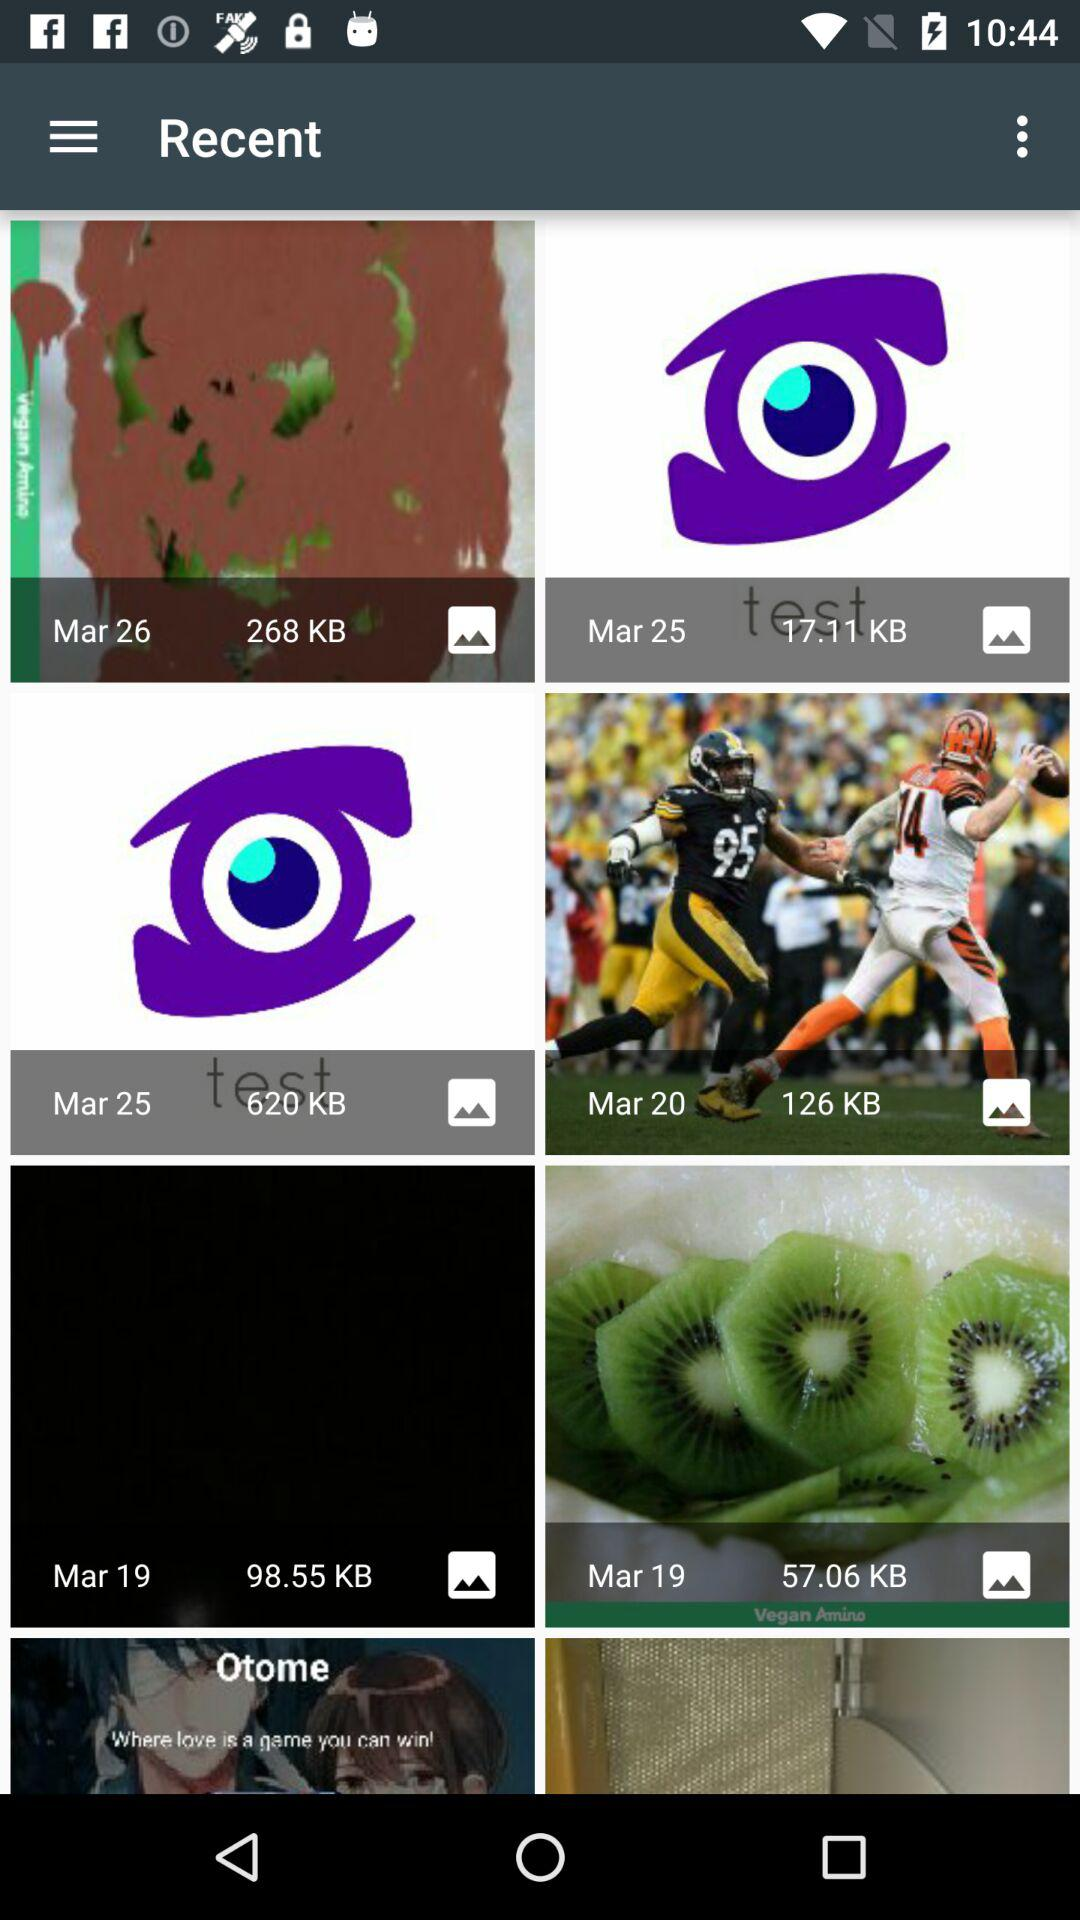What is the size of the image uploaded on March 20? The size of the image uploaded on March 20 is 126 KB. 